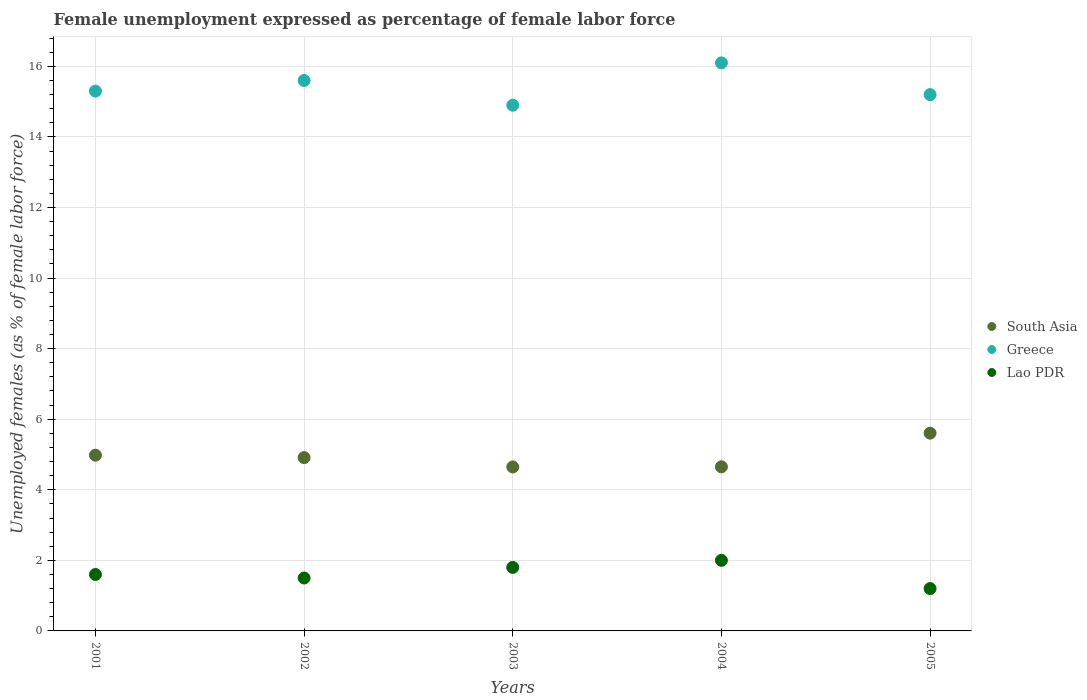How many different coloured dotlines are there?
Offer a very short reply. 3. Is the number of dotlines equal to the number of legend labels?
Your response must be concise. Yes. What is the unemployment in females in in Lao PDR in 2003?
Keep it short and to the point. 1.8. Across all years, what is the maximum unemployment in females in in South Asia?
Provide a short and direct response. 5.61. Across all years, what is the minimum unemployment in females in in Lao PDR?
Offer a very short reply. 1.2. In which year was the unemployment in females in in Lao PDR minimum?
Offer a very short reply. 2005. What is the total unemployment in females in in Greece in the graph?
Your response must be concise. 77.1. What is the difference between the unemployment in females in in South Asia in 2003 and that in 2004?
Give a very brief answer. -0. What is the difference between the unemployment in females in in Greece in 2002 and the unemployment in females in in Lao PDR in 2005?
Make the answer very short. 14.4. What is the average unemployment in females in in Lao PDR per year?
Your answer should be compact. 1.62. In the year 2004, what is the difference between the unemployment in females in in Greece and unemployment in females in in South Asia?
Offer a very short reply. 11.45. In how many years, is the unemployment in females in in Greece greater than 5.2 %?
Offer a very short reply. 5. What is the ratio of the unemployment in females in in Greece in 2002 to that in 2003?
Ensure brevity in your answer.  1.05. Is the unemployment in females in in Lao PDR in 2001 less than that in 2005?
Your answer should be compact. No. Is the difference between the unemployment in females in in Greece in 2002 and 2003 greater than the difference between the unemployment in females in in South Asia in 2002 and 2003?
Provide a short and direct response. Yes. What is the difference between the highest and the second highest unemployment in females in in South Asia?
Provide a succinct answer. 0.62. What is the difference between the highest and the lowest unemployment in females in in Lao PDR?
Your answer should be compact. 0.8. Is it the case that in every year, the sum of the unemployment in females in in Greece and unemployment in females in in Lao PDR  is greater than the unemployment in females in in South Asia?
Provide a succinct answer. Yes. Is the unemployment in females in in South Asia strictly greater than the unemployment in females in in Greece over the years?
Give a very brief answer. No. Is the unemployment in females in in Greece strictly less than the unemployment in females in in South Asia over the years?
Provide a succinct answer. No. How many dotlines are there?
Offer a very short reply. 3. How many years are there in the graph?
Ensure brevity in your answer.  5. Are the values on the major ticks of Y-axis written in scientific E-notation?
Provide a short and direct response. No. Does the graph contain any zero values?
Offer a terse response. No. Does the graph contain grids?
Your answer should be very brief. Yes. How many legend labels are there?
Keep it short and to the point. 3. How are the legend labels stacked?
Offer a terse response. Vertical. What is the title of the graph?
Provide a succinct answer. Female unemployment expressed as percentage of female labor force. Does "Mexico" appear as one of the legend labels in the graph?
Give a very brief answer. No. What is the label or title of the X-axis?
Offer a terse response. Years. What is the label or title of the Y-axis?
Give a very brief answer. Unemployed females (as % of female labor force). What is the Unemployed females (as % of female labor force) in South Asia in 2001?
Ensure brevity in your answer.  4.98. What is the Unemployed females (as % of female labor force) in Greece in 2001?
Offer a very short reply. 15.3. What is the Unemployed females (as % of female labor force) in Lao PDR in 2001?
Ensure brevity in your answer.  1.6. What is the Unemployed females (as % of female labor force) in South Asia in 2002?
Give a very brief answer. 4.91. What is the Unemployed females (as % of female labor force) of Greece in 2002?
Keep it short and to the point. 15.6. What is the Unemployed females (as % of female labor force) of Lao PDR in 2002?
Keep it short and to the point. 1.5. What is the Unemployed females (as % of female labor force) of South Asia in 2003?
Give a very brief answer. 4.65. What is the Unemployed females (as % of female labor force) in Greece in 2003?
Offer a very short reply. 14.9. What is the Unemployed females (as % of female labor force) of Lao PDR in 2003?
Provide a succinct answer. 1.8. What is the Unemployed females (as % of female labor force) in South Asia in 2004?
Your answer should be compact. 4.65. What is the Unemployed females (as % of female labor force) in Greece in 2004?
Provide a succinct answer. 16.1. What is the Unemployed females (as % of female labor force) in South Asia in 2005?
Make the answer very short. 5.61. What is the Unemployed females (as % of female labor force) in Greece in 2005?
Keep it short and to the point. 15.2. What is the Unemployed females (as % of female labor force) of Lao PDR in 2005?
Make the answer very short. 1.2. Across all years, what is the maximum Unemployed females (as % of female labor force) in South Asia?
Provide a short and direct response. 5.61. Across all years, what is the maximum Unemployed females (as % of female labor force) in Greece?
Give a very brief answer. 16.1. Across all years, what is the minimum Unemployed females (as % of female labor force) in South Asia?
Your answer should be very brief. 4.65. Across all years, what is the minimum Unemployed females (as % of female labor force) in Greece?
Offer a very short reply. 14.9. Across all years, what is the minimum Unemployed females (as % of female labor force) in Lao PDR?
Your answer should be very brief. 1.2. What is the total Unemployed females (as % of female labor force) of South Asia in the graph?
Your answer should be compact. 24.8. What is the total Unemployed females (as % of female labor force) of Greece in the graph?
Offer a terse response. 77.1. What is the total Unemployed females (as % of female labor force) of Lao PDR in the graph?
Give a very brief answer. 8.1. What is the difference between the Unemployed females (as % of female labor force) in South Asia in 2001 and that in 2002?
Offer a terse response. 0.07. What is the difference between the Unemployed females (as % of female labor force) of Lao PDR in 2001 and that in 2002?
Offer a very short reply. 0.1. What is the difference between the Unemployed females (as % of female labor force) in South Asia in 2001 and that in 2003?
Provide a short and direct response. 0.33. What is the difference between the Unemployed females (as % of female labor force) of Greece in 2001 and that in 2003?
Your answer should be compact. 0.4. What is the difference between the Unemployed females (as % of female labor force) of South Asia in 2001 and that in 2004?
Ensure brevity in your answer.  0.33. What is the difference between the Unemployed females (as % of female labor force) in Greece in 2001 and that in 2004?
Offer a terse response. -0.8. What is the difference between the Unemployed females (as % of female labor force) in South Asia in 2001 and that in 2005?
Provide a short and direct response. -0.62. What is the difference between the Unemployed females (as % of female labor force) in Lao PDR in 2001 and that in 2005?
Provide a succinct answer. 0.4. What is the difference between the Unemployed females (as % of female labor force) in South Asia in 2002 and that in 2003?
Your response must be concise. 0.27. What is the difference between the Unemployed females (as % of female labor force) of Lao PDR in 2002 and that in 2003?
Provide a short and direct response. -0.3. What is the difference between the Unemployed females (as % of female labor force) of South Asia in 2002 and that in 2004?
Ensure brevity in your answer.  0.26. What is the difference between the Unemployed females (as % of female labor force) of Lao PDR in 2002 and that in 2004?
Give a very brief answer. -0.5. What is the difference between the Unemployed females (as % of female labor force) of South Asia in 2002 and that in 2005?
Ensure brevity in your answer.  -0.69. What is the difference between the Unemployed females (as % of female labor force) in South Asia in 2003 and that in 2004?
Offer a very short reply. -0. What is the difference between the Unemployed females (as % of female labor force) of Lao PDR in 2003 and that in 2004?
Offer a terse response. -0.2. What is the difference between the Unemployed females (as % of female labor force) of South Asia in 2003 and that in 2005?
Provide a succinct answer. -0.96. What is the difference between the Unemployed females (as % of female labor force) in South Asia in 2004 and that in 2005?
Your answer should be very brief. -0.95. What is the difference between the Unemployed females (as % of female labor force) in Greece in 2004 and that in 2005?
Your answer should be very brief. 0.9. What is the difference between the Unemployed females (as % of female labor force) in South Asia in 2001 and the Unemployed females (as % of female labor force) in Greece in 2002?
Your answer should be compact. -10.62. What is the difference between the Unemployed females (as % of female labor force) of South Asia in 2001 and the Unemployed females (as % of female labor force) of Lao PDR in 2002?
Keep it short and to the point. 3.48. What is the difference between the Unemployed females (as % of female labor force) in Greece in 2001 and the Unemployed females (as % of female labor force) in Lao PDR in 2002?
Provide a succinct answer. 13.8. What is the difference between the Unemployed females (as % of female labor force) of South Asia in 2001 and the Unemployed females (as % of female labor force) of Greece in 2003?
Ensure brevity in your answer.  -9.92. What is the difference between the Unemployed females (as % of female labor force) of South Asia in 2001 and the Unemployed females (as % of female labor force) of Lao PDR in 2003?
Provide a short and direct response. 3.18. What is the difference between the Unemployed females (as % of female labor force) in South Asia in 2001 and the Unemployed females (as % of female labor force) in Greece in 2004?
Provide a short and direct response. -11.12. What is the difference between the Unemployed females (as % of female labor force) in South Asia in 2001 and the Unemployed females (as % of female labor force) in Lao PDR in 2004?
Provide a succinct answer. 2.98. What is the difference between the Unemployed females (as % of female labor force) in Greece in 2001 and the Unemployed females (as % of female labor force) in Lao PDR in 2004?
Offer a terse response. 13.3. What is the difference between the Unemployed females (as % of female labor force) in South Asia in 2001 and the Unemployed females (as % of female labor force) in Greece in 2005?
Provide a succinct answer. -10.22. What is the difference between the Unemployed females (as % of female labor force) of South Asia in 2001 and the Unemployed females (as % of female labor force) of Lao PDR in 2005?
Your answer should be very brief. 3.78. What is the difference between the Unemployed females (as % of female labor force) in South Asia in 2002 and the Unemployed females (as % of female labor force) in Greece in 2003?
Make the answer very short. -9.99. What is the difference between the Unemployed females (as % of female labor force) of South Asia in 2002 and the Unemployed females (as % of female labor force) of Lao PDR in 2003?
Your answer should be very brief. 3.11. What is the difference between the Unemployed females (as % of female labor force) of Greece in 2002 and the Unemployed females (as % of female labor force) of Lao PDR in 2003?
Provide a succinct answer. 13.8. What is the difference between the Unemployed females (as % of female labor force) in South Asia in 2002 and the Unemployed females (as % of female labor force) in Greece in 2004?
Ensure brevity in your answer.  -11.19. What is the difference between the Unemployed females (as % of female labor force) of South Asia in 2002 and the Unemployed females (as % of female labor force) of Lao PDR in 2004?
Provide a succinct answer. 2.91. What is the difference between the Unemployed females (as % of female labor force) in Greece in 2002 and the Unemployed females (as % of female labor force) in Lao PDR in 2004?
Your answer should be very brief. 13.6. What is the difference between the Unemployed females (as % of female labor force) of South Asia in 2002 and the Unemployed females (as % of female labor force) of Greece in 2005?
Offer a terse response. -10.29. What is the difference between the Unemployed females (as % of female labor force) of South Asia in 2002 and the Unemployed females (as % of female labor force) of Lao PDR in 2005?
Your answer should be very brief. 3.71. What is the difference between the Unemployed females (as % of female labor force) in Greece in 2002 and the Unemployed females (as % of female labor force) in Lao PDR in 2005?
Provide a short and direct response. 14.4. What is the difference between the Unemployed females (as % of female labor force) of South Asia in 2003 and the Unemployed females (as % of female labor force) of Greece in 2004?
Keep it short and to the point. -11.45. What is the difference between the Unemployed females (as % of female labor force) in South Asia in 2003 and the Unemployed females (as % of female labor force) in Lao PDR in 2004?
Offer a terse response. 2.65. What is the difference between the Unemployed females (as % of female labor force) of Greece in 2003 and the Unemployed females (as % of female labor force) of Lao PDR in 2004?
Make the answer very short. 12.9. What is the difference between the Unemployed females (as % of female labor force) in South Asia in 2003 and the Unemployed females (as % of female labor force) in Greece in 2005?
Keep it short and to the point. -10.55. What is the difference between the Unemployed females (as % of female labor force) of South Asia in 2003 and the Unemployed females (as % of female labor force) of Lao PDR in 2005?
Provide a short and direct response. 3.45. What is the difference between the Unemployed females (as % of female labor force) in Greece in 2003 and the Unemployed females (as % of female labor force) in Lao PDR in 2005?
Make the answer very short. 13.7. What is the difference between the Unemployed females (as % of female labor force) of South Asia in 2004 and the Unemployed females (as % of female labor force) of Greece in 2005?
Offer a very short reply. -10.55. What is the difference between the Unemployed females (as % of female labor force) of South Asia in 2004 and the Unemployed females (as % of female labor force) of Lao PDR in 2005?
Your answer should be very brief. 3.45. What is the difference between the Unemployed females (as % of female labor force) in Greece in 2004 and the Unemployed females (as % of female labor force) in Lao PDR in 2005?
Ensure brevity in your answer.  14.9. What is the average Unemployed females (as % of female labor force) of South Asia per year?
Ensure brevity in your answer.  4.96. What is the average Unemployed females (as % of female labor force) of Greece per year?
Keep it short and to the point. 15.42. What is the average Unemployed females (as % of female labor force) of Lao PDR per year?
Make the answer very short. 1.62. In the year 2001, what is the difference between the Unemployed females (as % of female labor force) of South Asia and Unemployed females (as % of female labor force) of Greece?
Provide a succinct answer. -10.32. In the year 2001, what is the difference between the Unemployed females (as % of female labor force) of South Asia and Unemployed females (as % of female labor force) of Lao PDR?
Make the answer very short. 3.38. In the year 2002, what is the difference between the Unemployed females (as % of female labor force) of South Asia and Unemployed females (as % of female labor force) of Greece?
Your answer should be compact. -10.69. In the year 2002, what is the difference between the Unemployed females (as % of female labor force) in South Asia and Unemployed females (as % of female labor force) in Lao PDR?
Provide a succinct answer. 3.41. In the year 2002, what is the difference between the Unemployed females (as % of female labor force) in Greece and Unemployed females (as % of female labor force) in Lao PDR?
Keep it short and to the point. 14.1. In the year 2003, what is the difference between the Unemployed females (as % of female labor force) in South Asia and Unemployed females (as % of female labor force) in Greece?
Make the answer very short. -10.25. In the year 2003, what is the difference between the Unemployed females (as % of female labor force) in South Asia and Unemployed females (as % of female labor force) in Lao PDR?
Your answer should be compact. 2.85. In the year 2004, what is the difference between the Unemployed females (as % of female labor force) in South Asia and Unemployed females (as % of female labor force) in Greece?
Keep it short and to the point. -11.45. In the year 2004, what is the difference between the Unemployed females (as % of female labor force) of South Asia and Unemployed females (as % of female labor force) of Lao PDR?
Keep it short and to the point. 2.65. In the year 2005, what is the difference between the Unemployed females (as % of female labor force) of South Asia and Unemployed females (as % of female labor force) of Greece?
Offer a very short reply. -9.59. In the year 2005, what is the difference between the Unemployed females (as % of female labor force) in South Asia and Unemployed females (as % of female labor force) in Lao PDR?
Provide a short and direct response. 4.41. In the year 2005, what is the difference between the Unemployed females (as % of female labor force) in Greece and Unemployed females (as % of female labor force) in Lao PDR?
Provide a short and direct response. 14. What is the ratio of the Unemployed females (as % of female labor force) in Greece in 2001 to that in 2002?
Provide a succinct answer. 0.98. What is the ratio of the Unemployed females (as % of female labor force) of Lao PDR in 2001 to that in 2002?
Provide a short and direct response. 1.07. What is the ratio of the Unemployed females (as % of female labor force) of South Asia in 2001 to that in 2003?
Provide a succinct answer. 1.07. What is the ratio of the Unemployed females (as % of female labor force) in Greece in 2001 to that in 2003?
Ensure brevity in your answer.  1.03. What is the ratio of the Unemployed females (as % of female labor force) of South Asia in 2001 to that in 2004?
Make the answer very short. 1.07. What is the ratio of the Unemployed females (as % of female labor force) of Greece in 2001 to that in 2004?
Make the answer very short. 0.95. What is the ratio of the Unemployed females (as % of female labor force) in Lao PDR in 2001 to that in 2004?
Your answer should be compact. 0.8. What is the ratio of the Unemployed females (as % of female labor force) of South Asia in 2001 to that in 2005?
Offer a very short reply. 0.89. What is the ratio of the Unemployed females (as % of female labor force) of Greece in 2001 to that in 2005?
Offer a very short reply. 1.01. What is the ratio of the Unemployed females (as % of female labor force) of Lao PDR in 2001 to that in 2005?
Your response must be concise. 1.33. What is the ratio of the Unemployed females (as % of female labor force) in South Asia in 2002 to that in 2003?
Ensure brevity in your answer.  1.06. What is the ratio of the Unemployed females (as % of female labor force) in Greece in 2002 to that in 2003?
Your answer should be compact. 1.05. What is the ratio of the Unemployed females (as % of female labor force) of South Asia in 2002 to that in 2004?
Ensure brevity in your answer.  1.06. What is the ratio of the Unemployed females (as % of female labor force) in Greece in 2002 to that in 2004?
Offer a terse response. 0.97. What is the ratio of the Unemployed females (as % of female labor force) of South Asia in 2002 to that in 2005?
Offer a very short reply. 0.88. What is the ratio of the Unemployed females (as % of female labor force) in Greece in 2002 to that in 2005?
Provide a short and direct response. 1.03. What is the ratio of the Unemployed females (as % of female labor force) of South Asia in 2003 to that in 2004?
Offer a very short reply. 1. What is the ratio of the Unemployed females (as % of female labor force) of Greece in 2003 to that in 2004?
Offer a very short reply. 0.93. What is the ratio of the Unemployed females (as % of female labor force) of South Asia in 2003 to that in 2005?
Keep it short and to the point. 0.83. What is the ratio of the Unemployed females (as % of female labor force) in Greece in 2003 to that in 2005?
Provide a succinct answer. 0.98. What is the ratio of the Unemployed females (as % of female labor force) in South Asia in 2004 to that in 2005?
Your answer should be compact. 0.83. What is the ratio of the Unemployed females (as % of female labor force) in Greece in 2004 to that in 2005?
Provide a short and direct response. 1.06. What is the ratio of the Unemployed females (as % of female labor force) in Lao PDR in 2004 to that in 2005?
Offer a very short reply. 1.67. What is the difference between the highest and the second highest Unemployed females (as % of female labor force) of South Asia?
Keep it short and to the point. 0.62. What is the difference between the highest and the lowest Unemployed females (as % of female labor force) in South Asia?
Provide a short and direct response. 0.96. What is the difference between the highest and the lowest Unemployed females (as % of female labor force) in Lao PDR?
Give a very brief answer. 0.8. 